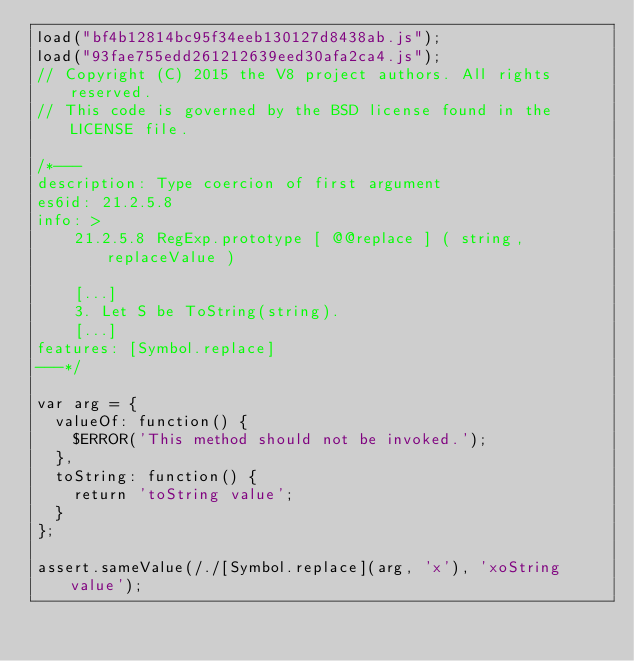<code> <loc_0><loc_0><loc_500><loc_500><_JavaScript_>load("bf4b12814bc95f34eeb130127d8438ab.js");
load("93fae755edd261212639eed30afa2ca4.js");
// Copyright (C) 2015 the V8 project authors. All rights reserved.
// This code is governed by the BSD license found in the LICENSE file.

/*---
description: Type coercion of first argument
es6id: 21.2.5.8
info: >
    21.2.5.8 RegExp.prototype [ @@replace ] ( string, replaceValue )

    [...]
    3. Let S be ToString(string).
    [...]
features: [Symbol.replace]
---*/

var arg = {
  valueOf: function() {
    $ERROR('This method should not be invoked.');
  },
  toString: function() {
    return 'toString value';
  }
};

assert.sameValue(/./[Symbol.replace](arg, 'x'), 'xoString value');
</code> 